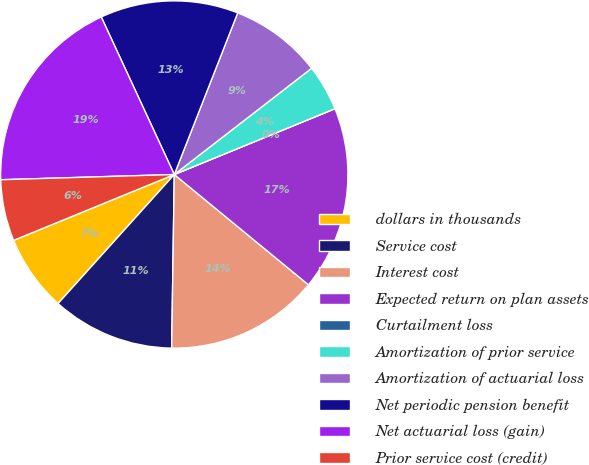Convert chart. <chart><loc_0><loc_0><loc_500><loc_500><pie_chart><fcel>dollars in thousands<fcel>Service cost<fcel>Interest cost<fcel>Expected return on plan assets<fcel>Curtailment loss<fcel>Amortization of prior service<fcel>Amortization of actuarial loss<fcel>Net periodic pension benefit<fcel>Net actuarial loss (gain)<fcel>Prior service cost (credit)<nl><fcel>7.14%<fcel>11.43%<fcel>14.29%<fcel>17.14%<fcel>0.0%<fcel>4.29%<fcel>8.57%<fcel>12.86%<fcel>18.57%<fcel>5.71%<nl></chart> 